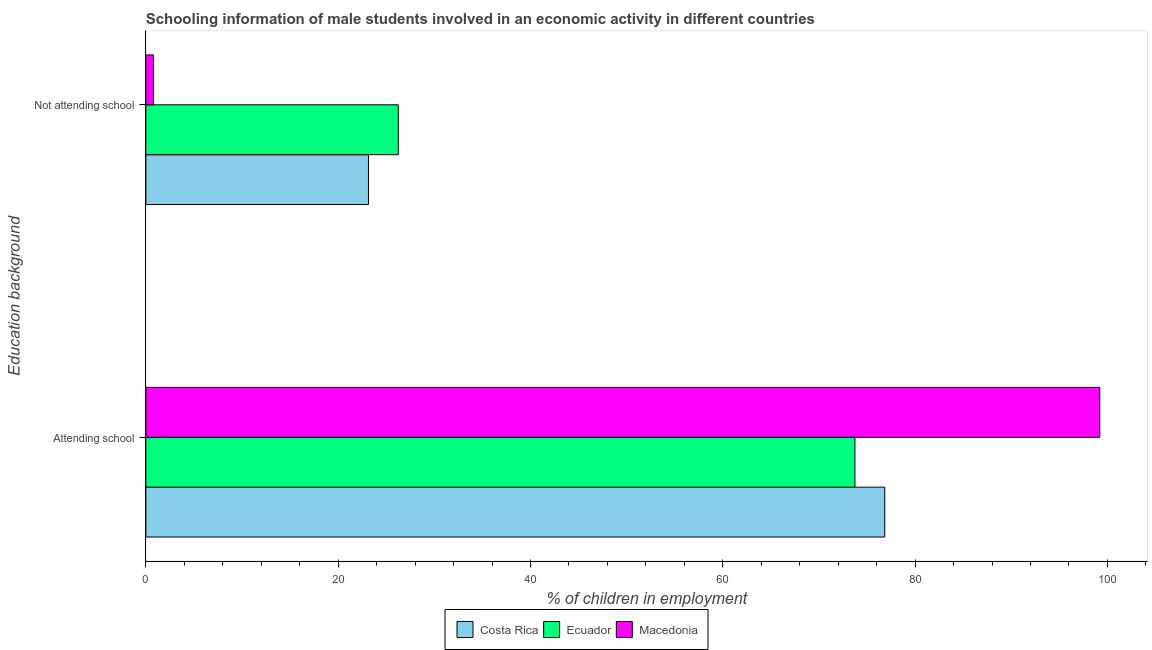How many groups of bars are there?
Your answer should be compact. 2. How many bars are there on the 2nd tick from the top?
Keep it short and to the point. 3. What is the label of the 2nd group of bars from the top?
Offer a very short reply. Attending school. What is the percentage of employed males who are attending school in Ecuador?
Offer a terse response. 73.75. Across all countries, what is the maximum percentage of employed males who are not attending school?
Your answer should be very brief. 26.25. Across all countries, what is the minimum percentage of employed males who are attending school?
Provide a succinct answer. 73.75. In which country was the percentage of employed males who are not attending school maximum?
Your answer should be compact. Ecuador. In which country was the percentage of employed males who are attending school minimum?
Provide a succinct answer. Ecuador. What is the total percentage of employed males who are not attending school in the graph?
Offer a terse response. 50.2. What is the difference between the percentage of employed males who are attending school in Macedonia and that in Costa Rica?
Give a very brief answer. 22.36. What is the difference between the percentage of employed males who are not attending school in Costa Rica and the percentage of employed males who are attending school in Ecuador?
Make the answer very short. -50.59. What is the average percentage of employed males who are not attending school per country?
Provide a succinct answer. 16.73. What is the difference between the percentage of employed males who are not attending school and percentage of employed males who are attending school in Costa Rica?
Your answer should be compact. -53.69. In how many countries, is the percentage of employed males who are not attending school greater than 64 %?
Your answer should be compact. 0. What is the ratio of the percentage of employed males who are attending school in Costa Rica to that in Macedonia?
Your answer should be compact. 0.77. Is the percentage of employed males who are attending school in Macedonia less than that in Costa Rica?
Provide a short and direct response. No. What does the 2nd bar from the bottom in Attending school represents?
Your answer should be very brief. Ecuador. Are all the bars in the graph horizontal?
Your answer should be very brief. Yes. What is the difference between two consecutive major ticks on the X-axis?
Keep it short and to the point. 20. Does the graph contain any zero values?
Give a very brief answer. No. How many legend labels are there?
Your response must be concise. 3. What is the title of the graph?
Ensure brevity in your answer.  Schooling information of male students involved in an economic activity in different countries. Does "Congo (Republic)" appear as one of the legend labels in the graph?
Keep it short and to the point. No. What is the label or title of the X-axis?
Keep it short and to the point. % of children in employment. What is the label or title of the Y-axis?
Offer a very short reply. Education background. What is the % of children in employment of Costa Rica in Attending school?
Keep it short and to the point. 76.85. What is the % of children in employment in Ecuador in Attending school?
Your answer should be compact. 73.75. What is the % of children in employment in Macedonia in Attending school?
Keep it short and to the point. 99.21. What is the % of children in employment of Costa Rica in Not attending school?
Your answer should be very brief. 23.15. What is the % of children in employment of Ecuador in Not attending school?
Make the answer very short. 26.25. What is the % of children in employment of Macedonia in Not attending school?
Your answer should be compact. 0.79. Across all Education background, what is the maximum % of children in employment in Costa Rica?
Provide a short and direct response. 76.85. Across all Education background, what is the maximum % of children in employment in Ecuador?
Offer a very short reply. 73.75. Across all Education background, what is the maximum % of children in employment of Macedonia?
Provide a succinct answer. 99.21. Across all Education background, what is the minimum % of children in employment of Costa Rica?
Offer a very short reply. 23.15. Across all Education background, what is the minimum % of children in employment in Ecuador?
Provide a succinct answer. 26.25. Across all Education background, what is the minimum % of children in employment in Macedonia?
Your answer should be very brief. 0.79. What is the difference between the % of children in employment of Costa Rica in Attending school and that in Not attending school?
Offer a terse response. 53.69. What is the difference between the % of children in employment of Ecuador in Attending school and that in Not attending school?
Provide a short and direct response. 47.49. What is the difference between the % of children in employment in Macedonia in Attending school and that in Not attending school?
Provide a succinct answer. 98.42. What is the difference between the % of children in employment of Costa Rica in Attending school and the % of children in employment of Ecuador in Not attending school?
Your answer should be compact. 50.59. What is the difference between the % of children in employment of Costa Rica in Attending school and the % of children in employment of Macedonia in Not attending school?
Your answer should be compact. 76.06. What is the difference between the % of children in employment in Ecuador in Attending school and the % of children in employment in Macedonia in Not attending school?
Offer a terse response. 72.96. What is the average % of children in employment in Costa Rica per Education background?
Your answer should be very brief. 50. What is the difference between the % of children in employment in Costa Rica and % of children in employment in Ecuador in Attending school?
Your answer should be very brief. 3.1. What is the difference between the % of children in employment of Costa Rica and % of children in employment of Macedonia in Attending school?
Give a very brief answer. -22.36. What is the difference between the % of children in employment of Ecuador and % of children in employment of Macedonia in Attending school?
Give a very brief answer. -25.46. What is the difference between the % of children in employment of Costa Rica and % of children in employment of Ecuador in Not attending school?
Offer a terse response. -3.1. What is the difference between the % of children in employment in Costa Rica and % of children in employment in Macedonia in Not attending school?
Keep it short and to the point. 22.36. What is the difference between the % of children in employment of Ecuador and % of children in employment of Macedonia in Not attending school?
Keep it short and to the point. 25.46. What is the ratio of the % of children in employment of Costa Rica in Attending school to that in Not attending school?
Provide a succinct answer. 3.32. What is the ratio of the % of children in employment in Ecuador in Attending school to that in Not attending school?
Give a very brief answer. 2.81. What is the ratio of the % of children in employment in Macedonia in Attending school to that in Not attending school?
Provide a short and direct response. 125.48. What is the difference between the highest and the second highest % of children in employment in Costa Rica?
Your answer should be compact. 53.69. What is the difference between the highest and the second highest % of children in employment of Ecuador?
Ensure brevity in your answer.  47.49. What is the difference between the highest and the second highest % of children in employment of Macedonia?
Make the answer very short. 98.42. What is the difference between the highest and the lowest % of children in employment in Costa Rica?
Your answer should be compact. 53.69. What is the difference between the highest and the lowest % of children in employment in Ecuador?
Your answer should be very brief. 47.49. What is the difference between the highest and the lowest % of children in employment of Macedonia?
Your response must be concise. 98.42. 